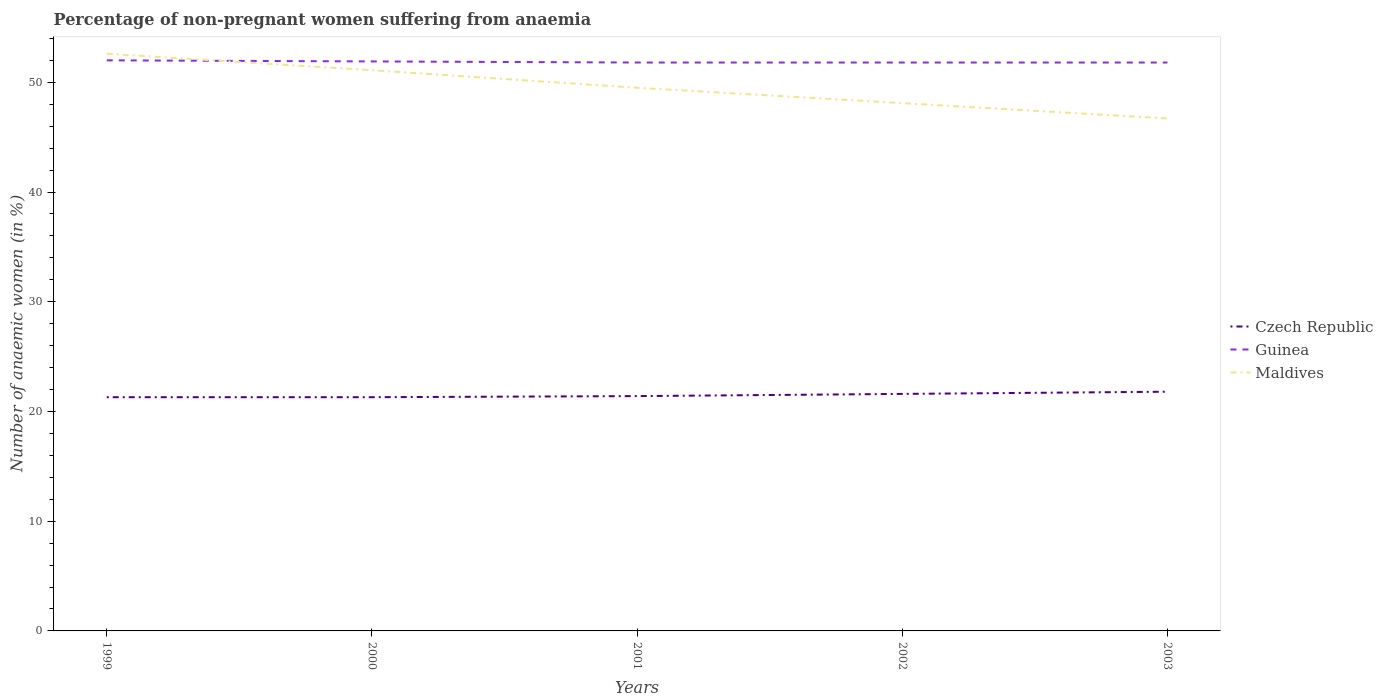How many different coloured lines are there?
Your response must be concise. 3. Does the line corresponding to Czech Republic intersect with the line corresponding to Maldives?
Your response must be concise. No. Is the number of lines equal to the number of legend labels?
Give a very brief answer. Yes. Across all years, what is the maximum percentage of non-pregnant women suffering from anaemia in Guinea?
Keep it short and to the point. 51.8. What is the total percentage of non-pregnant women suffering from anaemia in Guinea in the graph?
Provide a succinct answer. 0.2. What is the difference between the highest and the second highest percentage of non-pregnant women suffering from anaemia in Maldives?
Offer a terse response. 5.9. What is the difference between the highest and the lowest percentage of non-pregnant women suffering from anaemia in Czech Republic?
Ensure brevity in your answer.  2. Is the percentage of non-pregnant women suffering from anaemia in Maldives strictly greater than the percentage of non-pregnant women suffering from anaemia in Czech Republic over the years?
Ensure brevity in your answer.  No. What is the difference between two consecutive major ticks on the Y-axis?
Give a very brief answer. 10. What is the title of the graph?
Provide a succinct answer. Percentage of non-pregnant women suffering from anaemia. Does "Uganda" appear as one of the legend labels in the graph?
Give a very brief answer. No. What is the label or title of the X-axis?
Provide a succinct answer. Years. What is the label or title of the Y-axis?
Offer a very short reply. Number of anaemic women (in %). What is the Number of anaemic women (in %) in Czech Republic in 1999?
Offer a very short reply. 21.3. What is the Number of anaemic women (in %) of Guinea in 1999?
Make the answer very short. 52. What is the Number of anaemic women (in %) of Maldives in 1999?
Keep it short and to the point. 52.6. What is the Number of anaemic women (in %) of Czech Republic in 2000?
Ensure brevity in your answer.  21.3. What is the Number of anaemic women (in %) in Guinea in 2000?
Your answer should be very brief. 51.9. What is the Number of anaemic women (in %) in Maldives in 2000?
Provide a short and direct response. 51.1. What is the Number of anaemic women (in %) of Czech Republic in 2001?
Ensure brevity in your answer.  21.4. What is the Number of anaemic women (in %) in Guinea in 2001?
Give a very brief answer. 51.8. What is the Number of anaemic women (in %) of Maldives in 2001?
Provide a short and direct response. 49.5. What is the Number of anaemic women (in %) in Czech Republic in 2002?
Offer a terse response. 21.6. What is the Number of anaemic women (in %) in Guinea in 2002?
Offer a very short reply. 51.8. What is the Number of anaemic women (in %) of Maldives in 2002?
Give a very brief answer. 48.1. What is the Number of anaemic women (in %) in Czech Republic in 2003?
Your response must be concise. 21.8. What is the Number of anaemic women (in %) of Guinea in 2003?
Ensure brevity in your answer.  51.8. What is the Number of anaemic women (in %) of Maldives in 2003?
Your answer should be compact. 46.7. Across all years, what is the maximum Number of anaemic women (in %) of Czech Republic?
Offer a very short reply. 21.8. Across all years, what is the maximum Number of anaemic women (in %) in Guinea?
Your response must be concise. 52. Across all years, what is the maximum Number of anaemic women (in %) in Maldives?
Provide a succinct answer. 52.6. Across all years, what is the minimum Number of anaemic women (in %) in Czech Republic?
Your response must be concise. 21.3. Across all years, what is the minimum Number of anaemic women (in %) of Guinea?
Ensure brevity in your answer.  51.8. Across all years, what is the minimum Number of anaemic women (in %) in Maldives?
Ensure brevity in your answer.  46.7. What is the total Number of anaemic women (in %) in Czech Republic in the graph?
Offer a very short reply. 107.4. What is the total Number of anaemic women (in %) in Guinea in the graph?
Provide a short and direct response. 259.3. What is the total Number of anaemic women (in %) of Maldives in the graph?
Ensure brevity in your answer.  248. What is the difference between the Number of anaemic women (in %) in Maldives in 1999 and that in 2000?
Your response must be concise. 1.5. What is the difference between the Number of anaemic women (in %) in Czech Republic in 1999 and that in 2001?
Your answer should be compact. -0.1. What is the difference between the Number of anaemic women (in %) in Guinea in 1999 and that in 2001?
Provide a succinct answer. 0.2. What is the difference between the Number of anaemic women (in %) in Guinea in 1999 and that in 2002?
Provide a succinct answer. 0.2. What is the difference between the Number of anaemic women (in %) in Maldives in 1999 and that in 2002?
Offer a terse response. 4.5. What is the difference between the Number of anaemic women (in %) in Czech Republic in 1999 and that in 2003?
Your answer should be very brief. -0.5. What is the difference between the Number of anaemic women (in %) in Guinea in 1999 and that in 2003?
Keep it short and to the point. 0.2. What is the difference between the Number of anaemic women (in %) in Maldives in 1999 and that in 2003?
Provide a succinct answer. 5.9. What is the difference between the Number of anaemic women (in %) in Czech Republic in 2000 and that in 2001?
Offer a terse response. -0.1. What is the difference between the Number of anaemic women (in %) in Czech Republic in 2001 and that in 2002?
Ensure brevity in your answer.  -0.2. What is the difference between the Number of anaemic women (in %) of Guinea in 2001 and that in 2002?
Offer a very short reply. 0. What is the difference between the Number of anaemic women (in %) of Maldives in 2001 and that in 2002?
Make the answer very short. 1.4. What is the difference between the Number of anaemic women (in %) in Czech Republic in 2001 and that in 2003?
Your response must be concise. -0.4. What is the difference between the Number of anaemic women (in %) of Maldives in 2001 and that in 2003?
Provide a short and direct response. 2.8. What is the difference between the Number of anaemic women (in %) of Czech Republic in 2002 and that in 2003?
Give a very brief answer. -0.2. What is the difference between the Number of anaemic women (in %) of Guinea in 2002 and that in 2003?
Keep it short and to the point. 0. What is the difference between the Number of anaemic women (in %) in Maldives in 2002 and that in 2003?
Your answer should be very brief. 1.4. What is the difference between the Number of anaemic women (in %) in Czech Republic in 1999 and the Number of anaemic women (in %) in Guinea in 2000?
Your response must be concise. -30.6. What is the difference between the Number of anaemic women (in %) in Czech Republic in 1999 and the Number of anaemic women (in %) in Maldives in 2000?
Keep it short and to the point. -29.8. What is the difference between the Number of anaemic women (in %) in Guinea in 1999 and the Number of anaemic women (in %) in Maldives in 2000?
Provide a short and direct response. 0.9. What is the difference between the Number of anaemic women (in %) in Czech Republic in 1999 and the Number of anaemic women (in %) in Guinea in 2001?
Your answer should be compact. -30.5. What is the difference between the Number of anaemic women (in %) of Czech Republic in 1999 and the Number of anaemic women (in %) of Maldives in 2001?
Give a very brief answer. -28.2. What is the difference between the Number of anaemic women (in %) in Czech Republic in 1999 and the Number of anaemic women (in %) in Guinea in 2002?
Give a very brief answer. -30.5. What is the difference between the Number of anaemic women (in %) of Czech Republic in 1999 and the Number of anaemic women (in %) of Maldives in 2002?
Give a very brief answer. -26.8. What is the difference between the Number of anaemic women (in %) in Czech Republic in 1999 and the Number of anaemic women (in %) in Guinea in 2003?
Your response must be concise. -30.5. What is the difference between the Number of anaemic women (in %) in Czech Republic in 1999 and the Number of anaemic women (in %) in Maldives in 2003?
Ensure brevity in your answer.  -25.4. What is the difference between the Number of anaemic women (in %) of Czech Republic in 2000 and the Number of anaemic women (in %) of Guinea in 2001?
Give a very brief answer. -30.5. What is the difference between the Number of anaemic women (in %) of Czech Republic in 2000 and the Number of anaemic women (in %) of Maldives in 2001?
Offer a terse response. -28.2. What is the difference between the Number of anaemic women (in %) in Czech Republic in 2000 and the Number of anaemic women (in %) in Guinea in 2002?
Your response must be concise. -30.5. What is the difference between the Number of anaemic women (in %) of Czech Republic in 2000 and the Number of anaemic women (in %) of Maldives in 2002?
Provide a succinct answer. -26.8. What is the difference between the Number of anaemic women (in %) in Guinea in 2000 and the Number of anaemic women (in %) in Maldives in 2002?
Your answer should be very brief. 3.8. What is the difference between the Number of anaemic women (in %) of Czech Republic in 2000 and the Number of anaemic women (in %) of Guinea in 2003?
Your response must be concise. -30.5. What is the difference between the Number of anaemic women (in %) of Czech Republic in 2000 and the Number of anaemic women (in %) of Maldives in 2003?
Offer a very short reply. -25.4. What is the difference between the Number of anaemic women (in %) of Guinea in 2000 and the Number of anaemic women (in %) of Maldives in 2003?
Offer a very short reply. 5.2. What is the difference between the Number of anaemic women (in %) of Czech Republic in 2001 and the Number of anaemic women (in %) of Guinea in 2002?
Provide a short and direct response. -30.4. What is the difference between the Number of anaemic women (in %) of Czech Republic in 2001 and the Number of anaemic women (in %) of Maldives in 2002?
Your answer should be very brief. -26.7. What is the difference between the Number of anaemic women (in %) in Guinea in 2001 and the Number of anaemic women (in %) in Maldives in 2002?
Ensure brevity in your answer.  3.7. What is the difference between the Number of anaemic women (in %) in Czech Republic in 2001 and the Number of anaemic women (in %) in Guinea in 2003?
Keep it short and to the point. -30.4. What is the difference between the Number of anaemic women (in %) of Czech Republic in 2001 and the Number of anaemic women (in %) of Maldives in 2003?
Your response must be concise. -25.3. What is the difference between the Number of anaemic women (in %) in Czech Republic in 2002 and the Number of anaemic women (in %) in Guinea in 2003?
Keep it short and to the point. -30.2. What is the difference between the Number of anaemic women (in %) in Czech Republic in 2002 and the Number of anaemic women (in %) in Maldives in 2003?
Ensure brevity in your answer.  -25.1. What is the average Number of anaemic women (in %) of Czech Republic per year?
Provide a succinct answer. 21.48. What is the average Number of anaemic women (in %) of Guinea per year?
Make the answer very short. 51.86. What is the average Number of anaemic women (in %) in Maldives per year?
Keep it short and to the point. 49.6. In the year 1999, what is the difference between the Number of anaemic women (in %) in Czech Republic and Number of anaemic women (in %) in Guinea?
Provide a short and direct response. -30.7. In the year 1999, what is the difference between the Number of anaemic women (in %) of Czech Republic and Number of anaemic women (in %) of Maldives?
Keep it short and to the point. -31.3. In the year 1999, what is the difference between the Number of anaemic women (in %) in Guinea and Number of anaemic women (in %) in Maldives?
Offer a terse response. -0.6. In the year 2000, what is the difference between the Number of anaemic women (in %) of Czech Republic and Number of anaemic women (in %) of Guinea?
Offer a terse response. -30.6. In the year 2000, what is the difference between the Number of anaemic women (in %) in Czech Republic and Number of anaemic women (in %) in Maldives?
Your answer should be compact. -29.8. In the year 2000, what is the difference between the Number of anaemic women (in %) of Guinea and Number of anaemic women (in %) of Maldives?
Offer a very short reply. 0.8. In the year 2001, what is the difference between the Number of anaemic women (in %) of Czech Republic and Number of anaemic women (in %) of Guinea?
Make the answer very short. -30.4. In the year 2001, what is the difference between the Number of anaemic women (in %) in Czech Republic and Number of anaemic women (in %) in Maldives?
Your answer should be compact. -28.1. In the year 2002, what is the difference between the Number of anaemic women (in %) of Czech Republic and Number of anaemic women (in %) of Guinea?
Your response must be concise. -30.2. In the year 2002, what is the difference between the Number of anaemic women (in %) in Czech Republic and Number of anaemic women (in %) in Maldives?
Your response must be concise. -26.5. In the year 2002, what is the difference between the Number of anaemic women (in %) of Guinea and Number of anaemic women (in %) of Maldives?
Provide a short and direct response. 3.7. In the year 2003, what is the difference between the Number of anaemic women (in %) of Czech Republic and Number of anaemic women (in %) of Guinea?
Your answer should be very brief. -30. In the year 2003, what is the difference between the Number of anaemic women (in %) in Czech Republic and Number of anaemic women (in %) in Maldives?
Offer a very short reply. -24.9. What is the ratio of the Number of anaemic women (in %) of Czech Republic in 1999 to that in 2000?
Make the answer very short. 1. What is the ratio of the Number of anaemic women (in %) in Maldives in 1999 to that in 2000?
Make the answer very short. 1.03. What is the ratio of the Number of anaemic women (in %) in Guinea in 1999 to that in 2001?
Provide a short and direct response. 1. What is the ratio of the Number of anaemic women (in %) of Maldives in 1999 to that in 2001?
Your answer should be very brief. 1.06. What is the ratio of the Number of anaemic women (in %) of Czech Republic in 1999 to that in 2002?
Provide a short and direct response. 0.99. What is the ratio of the Number of anaemic women (in %) in Guinea in 1999 to that in 2002?
Make the answer very short. 1. What is the ratio of the Number of anaemic women (in %) of Maldives in 1999 to that in 2002?
Give a very brief answer. 1.09. What is the ratio of the Number of anaemic women (in %) in Czech Republic in 1999 to that in 2003?
Your response must be concise. 0.98. What is the ratio of the Number of anaemic women (in %) in Guinea in 1999 to that in 2003?
Give a very brief answer. 1. What is the ratio of the Number of anaemic women (in %) of Maldives in 1999 to that in 2003?
Make the answer very short. 1.13. What is the ratio of the Number of anaemic women (in %) in Maldives in 2000 to that in 2001?
Make the answer very short. 1.03. What is the ratio of the Number of anaemic women (in %) of Czech Republic in 2000 to that in 2002?
Make the answer very short. 0.99. What is the ratio of the Number of anaemic women (in %) in Guinea in 2000 to that in 2002?
Provide a succinct answer. 1. What is the ratio of the Number of anaemic women (in %) in Maldives in 2000 to that in 2002?
Your answer should be very brief. 1.06. What is the ratio of the Number of anaemic women (in %) in Czech Republic in 2000 to that in 2003?
Give a very brief answer. 0.98. What is the ratio of the Number of anaemic women (in %) of Guinea in 2000 to that in 2003?
Ensure brevity in your answer.  1. What is the ratio of the Number of anaemic women (in %) in Maldives in 2000 to that in 2003?
Offer a terse response. 1.09. What is the ratio of the Number of anaemic women (in %) of Czech Republic in 2001 to that in 2002?
Your response must be concise. 0.99. What is the ratio of the Number of anaemic women (in %) of Guinea in 2001 to that in 2002?
Offer a very short reply. 1. What is the ratio of the Number of anaemic women (in %) of Maldives in 2001 to that in 2002?
Offer a very short reply. 1.03. What is the ratio of the Number of anaemic women (in %) of Czech Republic in 2001 to that in 2003?
Your response must be concise. 0.98. What is the ratio of the Number of anaemic women (in %) in Guinea in 2001 to that in 2003?
Offer a very short reply. 1. What is the ratio of the Number of anaemic women (in %) of Maldives in 2001 to that in 2003?
Offer a very short reply. 1.06. What is the ratio of the Number of anaemic women (in %) in Guinea in 2002 to that in 2003?
Offer a terse response. 1. What is the difference between the highest and the second highest Number of anaemic women (in %) of Czech Republic?
Give a very brief answer. 0.2. What is the difference between the highest and the second highest Number of anaemic women (in %) of Guinea?
Keep it short and to the point. 0.1. What is the difference between the highest and the lowest Number of anaemic women (in %) in Maldives?
Keep it short and to the point. 5.9. 